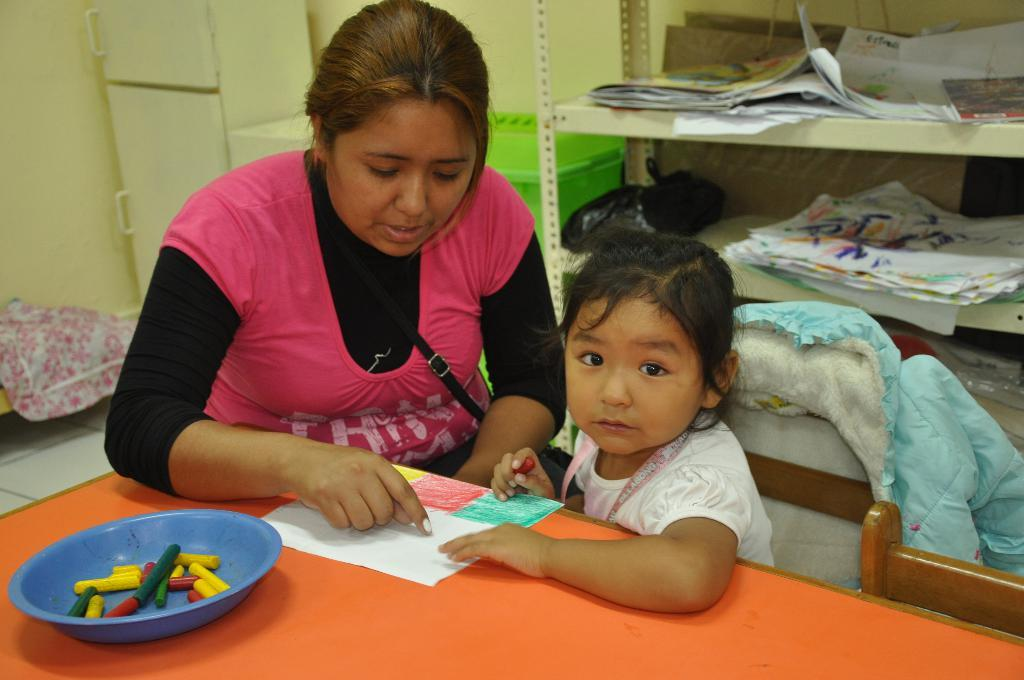Who is the main subject in the image? There is a lady in the center of the image. Are there any other people in the image? Yes, there is a girl in the image. What object can be seen on a table in the image? There is a bowl on a table in the image. What can be seen in the background of the image? There is a fridge, a wall, and a rack in the background of the image. What type of voice can be heard coming from the wilderness in the image? There is no wilderness or any indication of sound in the image, so it's not possible to determine what type of voice might be heard. Is there a light bulb visible in the image? There is no light bulb present in the image. 